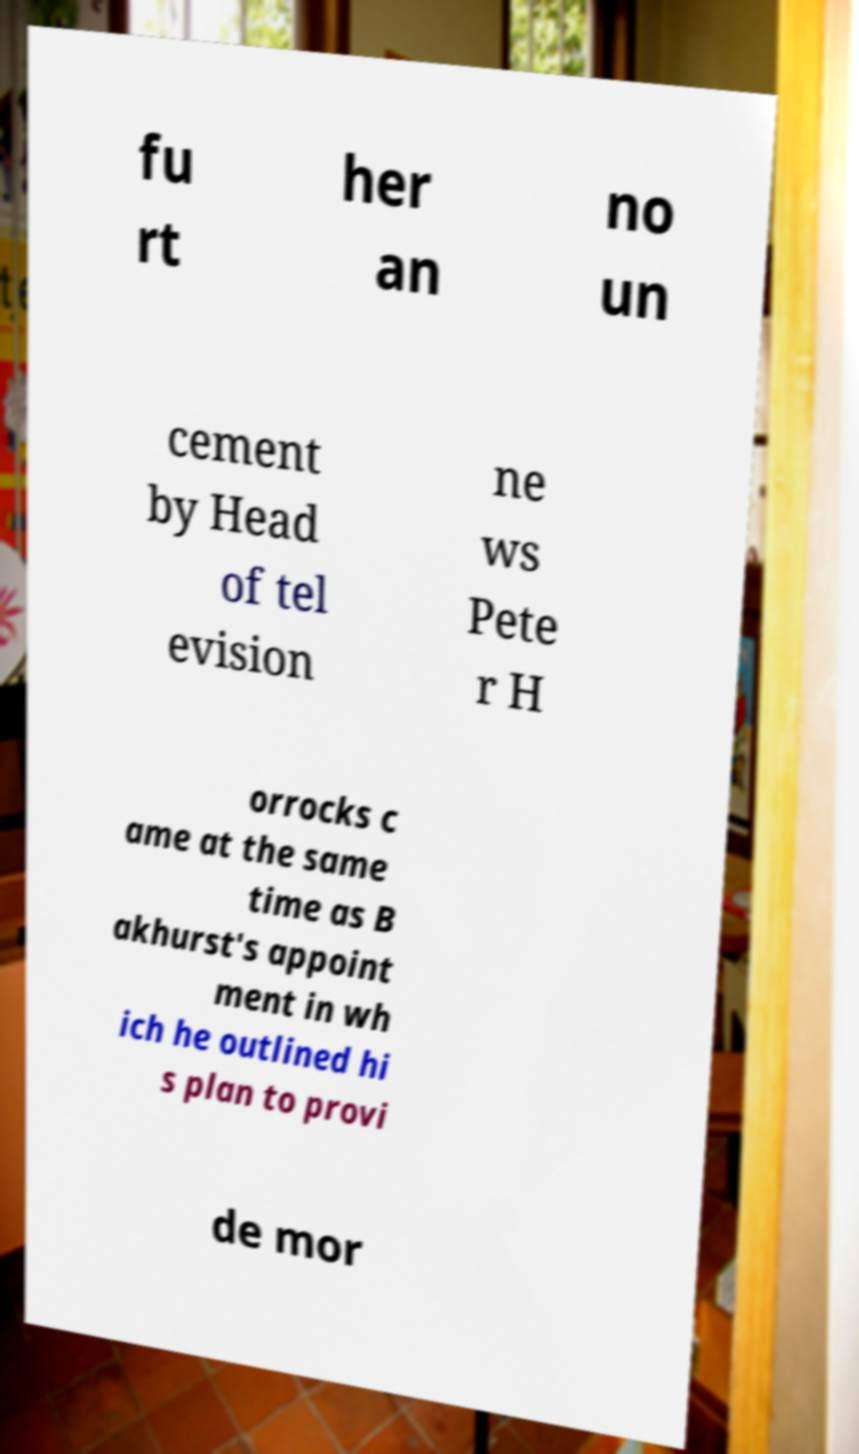Can you read and provide the text displayed in the image?This photo seems to have some interesting text. Can you extract and type it out for me? fu rt her an no un cement by Head of tel evision ne ws Pete r H orrocks c ame at the same time as B akhurst's appoint ment in wh ich he outlined hi s plan to provi de mor 